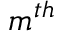<formula> <loc_0><loc_0><loc_500><loc_500>m ^ { t h }</formula> 